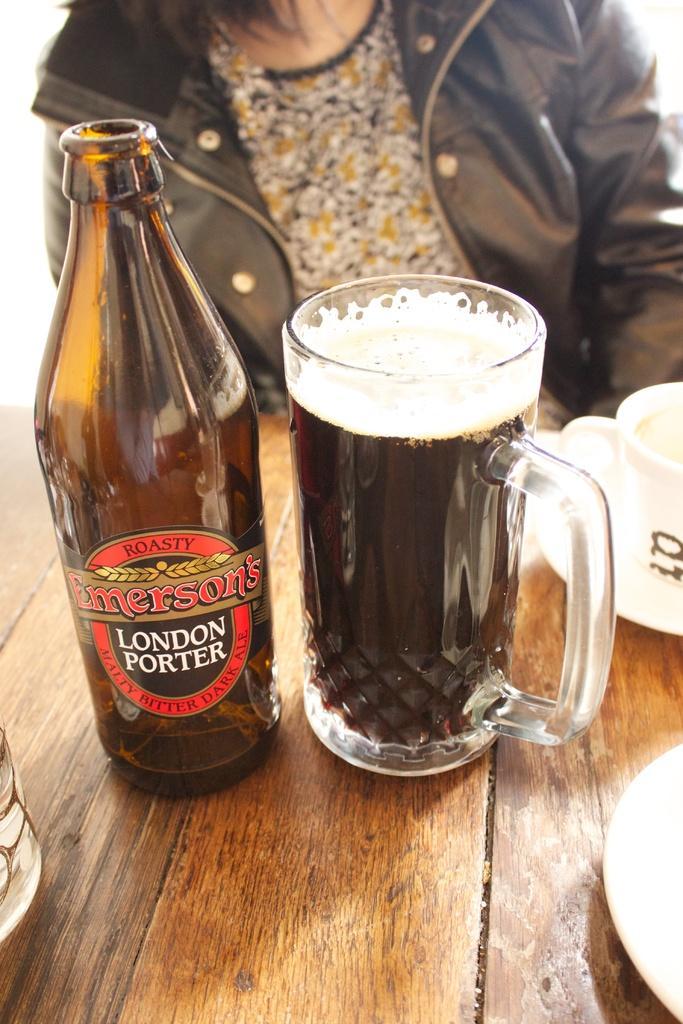In one or two sentences, can you explain what this image depicts? In this image I can see a bottle and a glass. In the background I can see a person and a cup. 